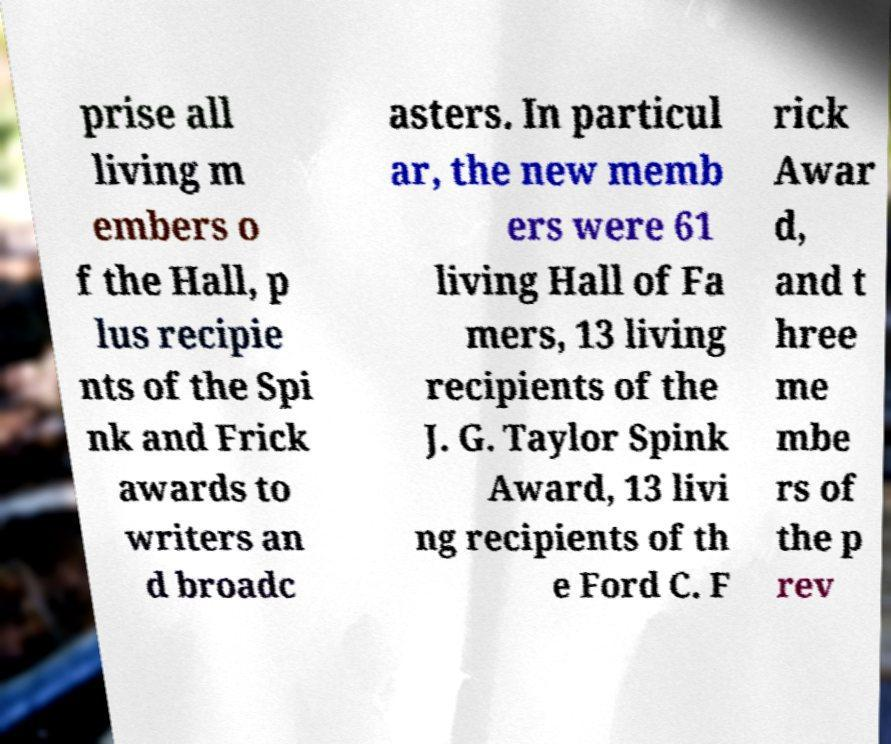Could you extract and type out the text from this image? prise all living m embers o f the Hall, p lus recipie nts of the Spi nk and Frick awards to writers an d broadc asters. In particul ar, the new memb ers were 61 living Hall of Fa mers, 13 living recipients of the J. G. Taylor Spink Award, 13 livi ng recipients of th e Ford C. F rick Awar d, and t hree me mbe rs of the p rev 